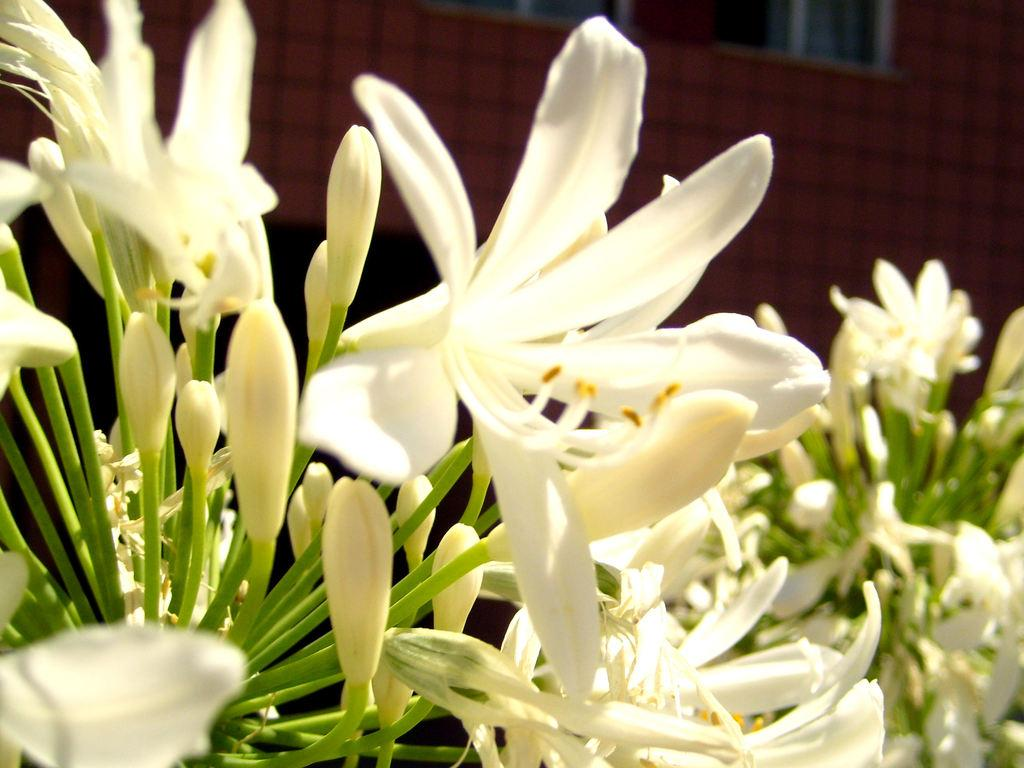What is present on the plants in the image? There are flowers and buds on the plants in the image. What can be seen in the background of the image? There are windows and a wall visible in the background of the image. What type of shoe can be seen on the plant in the image? There are no shoes present in the image; it features plants with flowers and buds. Can you tell me when the plants were born in the image? Plants do not have a concept of birth like animals or humans; they grow and develop over time. 